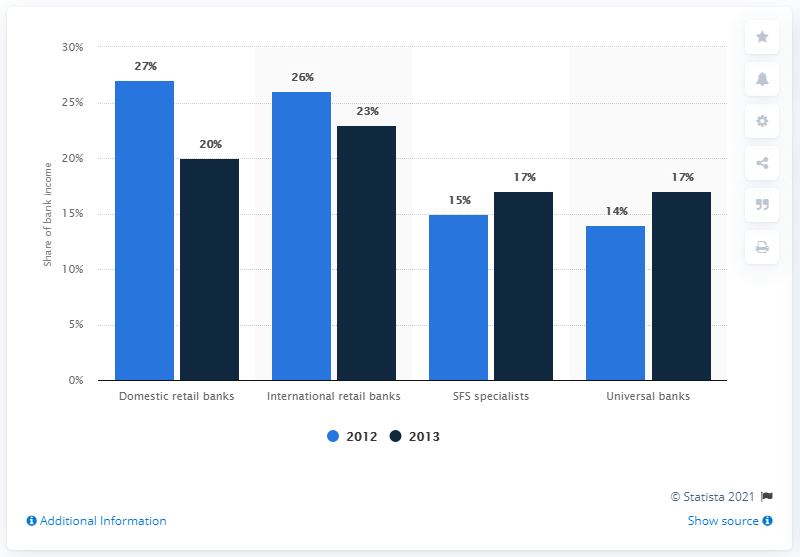Outline some significant characteristics in this image. In 2013, the cost of risk for international banks was approximately 23%. In 2013, the cost of risk for domestic retail banks was approximately X%. 